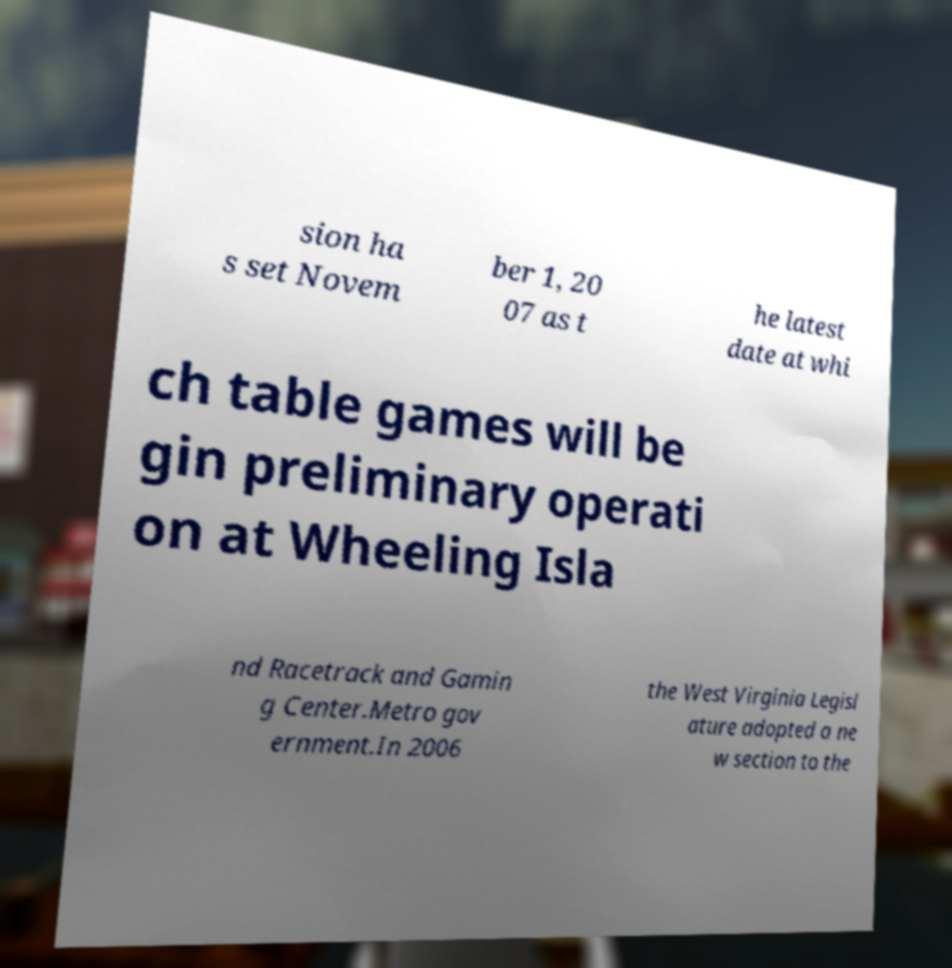For documentation purposes, I need the text within this image transcribed. Could you provide that? sion ha s set Novem ber 1, 20 07 as t he latest date at whi ch table games will be gin preliminary operati on at Wheeling Isla nd Racetrack and Gamin g Center.Metro gov ernment.In 2006 the West Virginia Legisl ature adopted a ne w section to the 